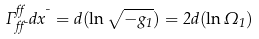Convert formula to latex. <formula><loc_0><loc_0><loc_500><loc_500>\Gamma ^ { \alpha } _ { \alpha \mu } d x ^ { \mu } = d ( \ln \sqrt { - g _ { 1 } } ) = 2 d ( \ln \Omega _ { 1 } )</formula> 